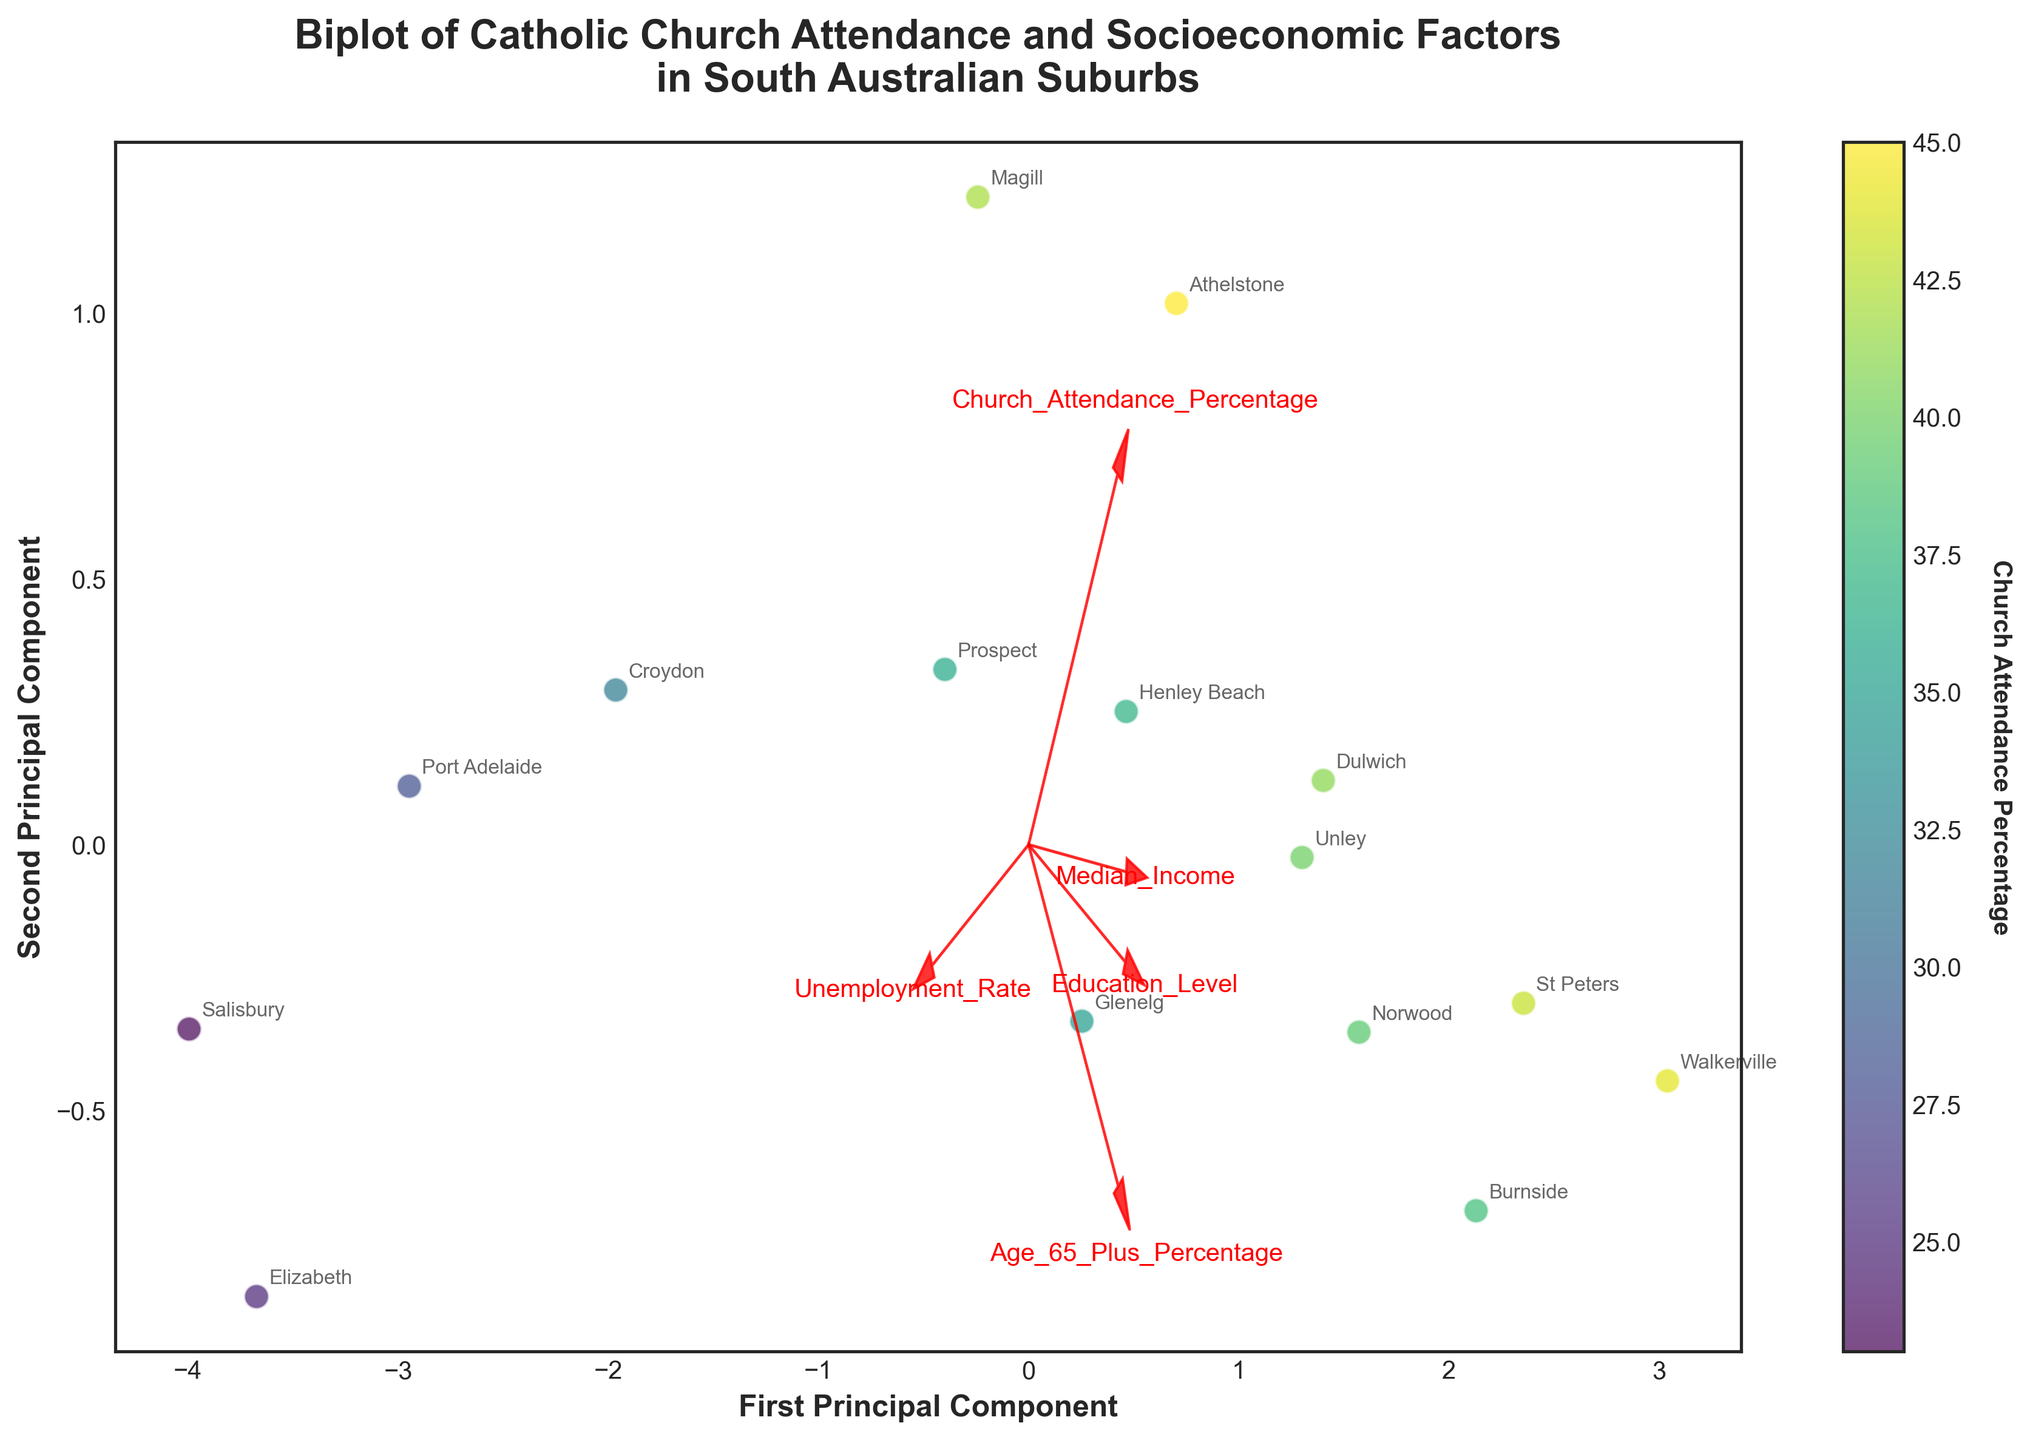Who has the lowest church attendance percentage? Look at the color of the points, Elizabeth has a very light color which indicates a lower church attendance percentage.
Answer: Elizabeth Which feature is most closely aligned with the first principal component? Observe the direction of the arrows along the first principal component axis. The 'Median_Income' arrow is nearly parallel to this axis, indicating strong alignment.
Answer: Median_Income Is there a correlation between church attendance percentage and Unemployment Rate? Observe the angles between the 'Church_Attendance_Percentage' and 'Unemployment_Rate' arrows. They form an obtuse angle, suggesting a negative correlation.
Answer: Negative correlation What does the color of the points represent? The figure's color bar indicates that the color of the points represents the church attendance percentage of each suburb.
Answer: Church attendance percentage Which suburb is located furthest along the first principal component axis? Look at the points distributed along the first principal component axis. Walkerville is furthest to the right, indicating it has the highest value in this component.
Answer: Walkerville Which feature is least aligned with the second principal component? Observe the direction of the arrows relative to the second principal component axis. 'Unemployment_Rate' is least aligned as its arrow is nearly perpendicular to this axis.
Answer: Unemployment_Rate Is Magill located closer to the first or the second principal component? Find Magill on the scatter plot and observe its coordinates relative to the axes. Magill is closer to the first principal component axis.
Answer: First principal component How many suburbs show church attendance of 40% or higher? Count the points with colors darker than the threshold, which corresponds to higher church attendance percentages. Based on the color intensity, there are 7 such suburbs.
Answer: 7 Which two socioeconomic factors are positively correlated according to their feature vectors? Examine the angles between the arrows of the different factors. 'Median_Income' and 'Education_Level' have arrows forming an acute angle, suggesting a positive correlation.
Answer: Median_Income and Education_Level What suburb has the highest percentage of residents aged 65 and over? Look at the position and label of the point furthest in the direction of the 'Age_65_Plus_Percentage' arrow. Walkerville is closest to this direction, indicating the highest percentage.
Answer: Walkerville 